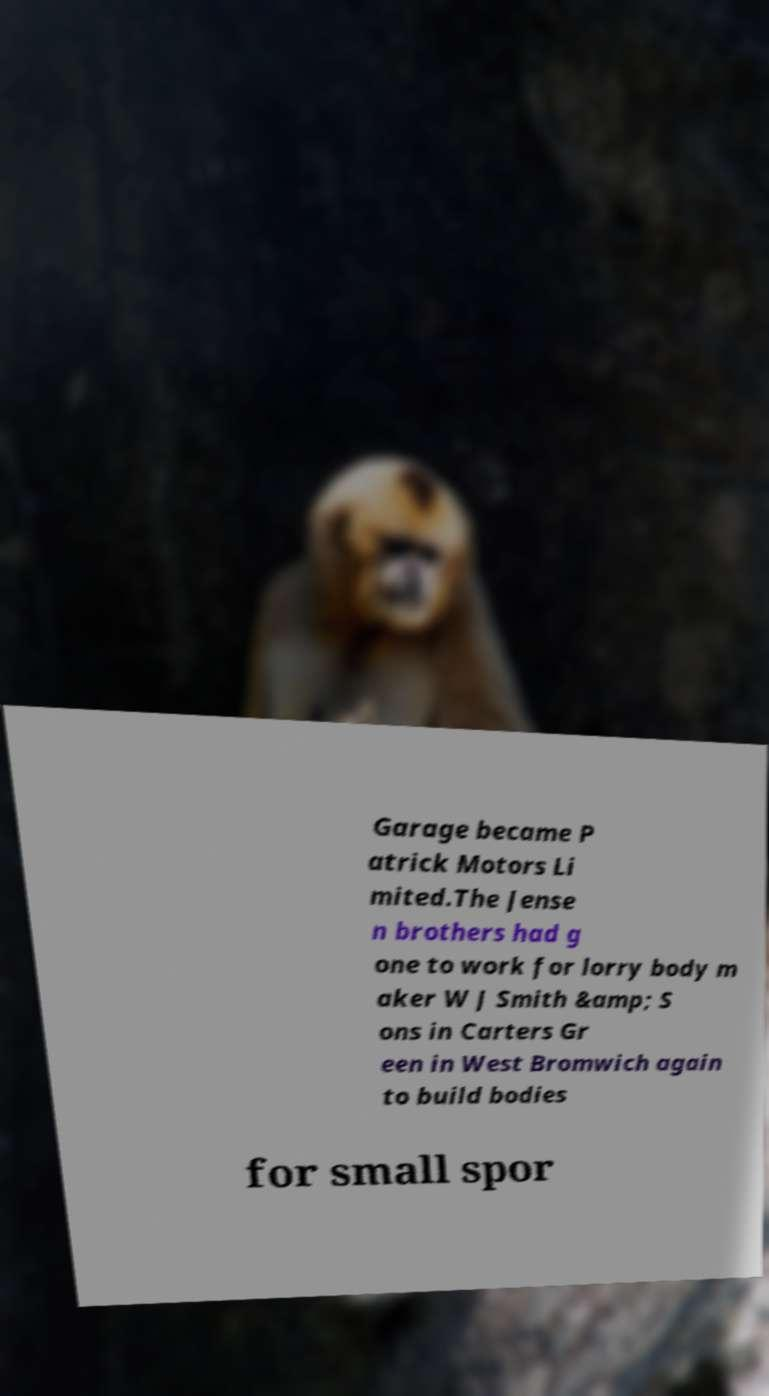For documentation purposes, I need the text within this image transcribed. Could you provide that? Garage became P atrick Motors Li mited.The Jense n brothers had g one to work for lorry body m aker W J Smith &amp; S ons in Carters Gr een in West Bromwich again to build bodies for small spor 